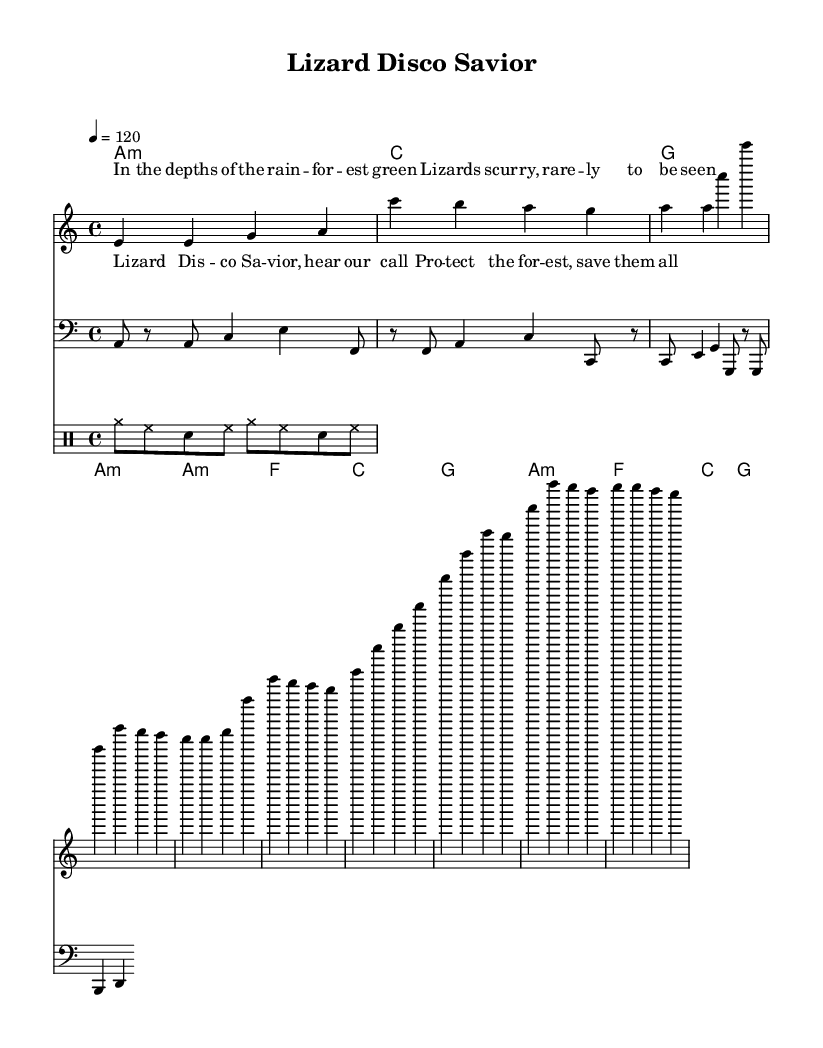What is the tempo of this piece? The tempo marking indicates that the piece should be played at 120 beats per minute (or quarter note). This can be found in the global settings at the start where it specifies the tempo as "4 = 120".
Answer: 120 What key is this music written in? The key signature is given as A minor, which can be inferred from the global settings where it states \key a \minor. This indicates that there are no sharps or flats.
Answer: A minor How many measures are in the verse? The verse section contains four measures, as seen in the melody part where the notes correspond to four distinct measures labeled in the music.
Answer: Four What instruments are included in this score? The score includes a melody staff, a bass staff, a drum staff, and chord names, all of which are indicated by their respective labels in the score. The instrumentation is typical for a disco arrangement aiming for a lively rhythm.
Answer: Melody, bass, drums What unique theme does this song convey? The lyrics explicitly reference lizards and conservation efforts in the tropical rainforest, with phrases like "protect the forest, save them all" indicating a deep connection to environmental themes. This is specific to the message of conservation prevalent in the lyrics.
Answer: Conservation 